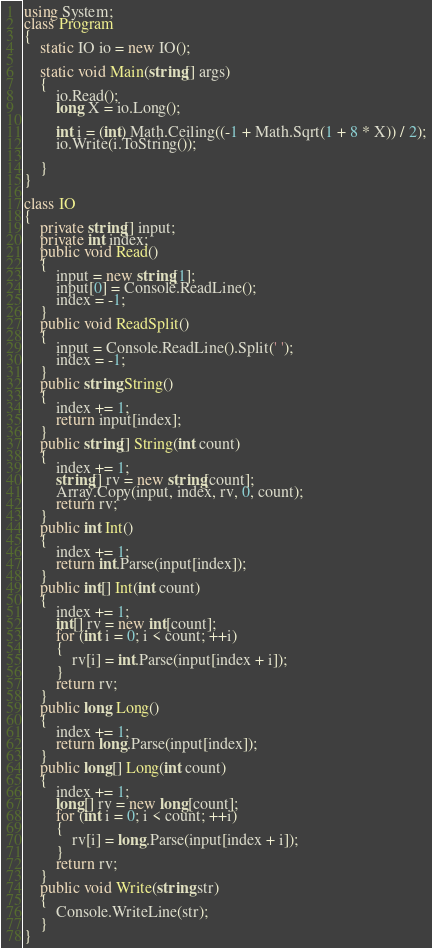Convert code to text. <code><loc_0><loc_0><loc_500><loc_500><_C#_>using System;
class Program
{
    static IO io = new IO();

    static void Main(string[] args)
    {
        io.Read();
        long X = io.Long();

        int i = (int) Math.Ceiling((-1 + Math.Sqrt(1 + 8 * X)) / 2);
        io.Write(i.ToString());

    }
}

class IO
{
    private string[] input;
    private int index;
    public void Read()
    {
        input = new string[1];
        input[0] = Console.ReadLine();
        index = -1;
    }
    public void ReadSplit()
    {
        input = Console.ReadLine().Split(' ');
        index = -1;
    }
    public string String()
    {
        index += 1;
        return input[index];
    }
    public string[] String(int count)
    {
        index += 1;
        string[] rv = new string[count];
        Array.Copy(input, index, rv, 0, count);
        return rv;
    }
    public int Int()
    {
        index += 1;
        return int.Parse(input[index]);
    }
    public int[] Int(int count)
    {
        index += 1;
        int[] rv = new int[count];
        for (int i = 0; i < count; ++i)
        {
            rv[i] = int.Parse(input[index + i]);
        }
        return rv;
    }
    public long Long()
    {
        index += 1;
        return long.Parse(input[index]);
    }
    public long[] Long(int count)
    {
        index += 1;
        long[] rv = new long[count];
        for (int i = 0; i < count; ++i)
        {
            rv[i] = long.Parse(input[index + i]);
        }
        return rv;
    }
    public void Write(string str)
    {
        Console.WriteLine(str);
    }
}</code> 